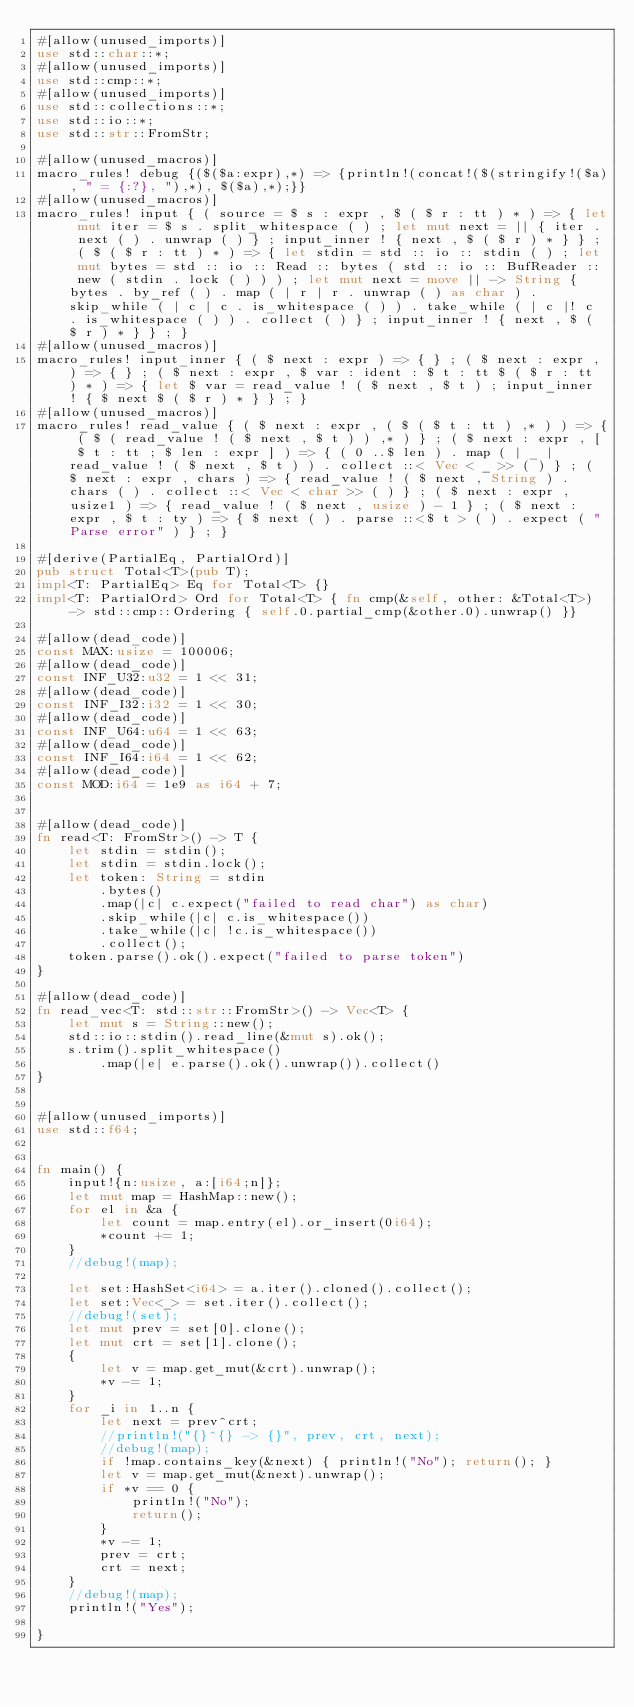<code> <loc_0><loc_0><loc_500><loc_500><_Rust_>#[allow(unused_imports)]
use std::char::*;
#[allow(unused_imports)]
use std::cmp::*;
#[allow(unused_imports)]
use std::collections::*;
use std::io::*;
use std::str::FromStr;

#[allow(unused_macros)]
macro_rules! debug {($($a:expr),*) => {println!(concat!($(stringify!($a), " = {:?}, "),*), $($a),*);}}
#[allow(unused_macros)]
macro_rules! input { ( source = $ s : expr , $ ( $ r : tt ) * ) => { let mut iter = $ s . split_whitespace ( ) ; let mut next = || { iter . next ( ) . unwrap ( ) } ; input_inner ! { next , $ ( $ r ) * } } ; ( $ ( $ r : tt ) * ) => { let stdin = std :: io :: stdin ( ) ; let mut bytes = std :: io :: Read :: bytes ( std :: io :: BufReader :: new ( stdin . lock ( ) ) ) ; let mut next = move || -> String { bytes . by_ref ( ) . map ( | r | r . unwrap ( ) as char ) . skip_while ( | c | c . is_whitespace ( ) ) . take_while ( | c |! c . is_whitespace ( ) ) . collect ( ) } ; input_inner ! { next , $ ( $ r ) * } } ; }
#[allow(unused_macros)]
macro_rules! input_inner { ( $ next : expr ) => { } ; ( $ next : expr , ) => { } ; ( $ next : expr , $ var : ident : $ t : tt $ ( $ r : tt ) * ) => { let $ var = read_value ! ( $ next , $ t ) ; input_inner ! { $ next $ ( $ r ) * } } ; }
#[allow(unused_macros)]
macro_rules! read_value { ( $ next : expr , ( $ ( $ t : tt ) ,* ) ) => { ( $ ( read_value ! ( $ next , $ t ) ) ,* ) } ; ( $ next : expr , [ $ t : tt ; $ len : expr ] ) => { ( 0 ..$ len ) . map ( | _ | read_value ! ( $ next , $ t ) ) . collect ::< Vec < _ >> ( ) } ; ( $ next : expr , chars ) => { read_value ! ( $ next , String ) . chars ( ) . collect ::< Vec < char >> ( ) } ; ( $ next : expr , usize1 ) => { read_value ! ( $ next , usize ) - 1 } ; ( $ next : expr , $ t : ty ) => { $ next ( ) . parse ::<$ t > ( ) . expect ( "Parse error" ) } ; }

#[derive(PartialEq, PartialOrd)]
pub struct Total<T>(pub T);
impl<T: PartialEq> Eq for Total<T> {}
impl<T: PartialOrd> Ord for Total<T> { fn cmp(&self, other: &Total<T>) -> std::cmp::Ordering { self.0.partial_cmp(&other.0).unwrap() }}

#[allow(dead_code)]
const MAX:usize = 100006;
#[allow(dead_code)]
const INF_U32:u32 = 1 << 31;
#[allow(dead_code)]
const INF_I32:i32 = 1 << 30;
#[allow(dead_code)]
const INF_U64:u64 = 1 << 63;
#[allow(dead_code)]
const INF_I64:i64 = 1 << 62;
#[allow(dead_code)]
const MOD:i64 = 1e9 as i64 + 7;


#[allow(dead_code)]
fn read<T: FromStr>() -> T {
    let stdin = stdin();
    let stdin = stdin.lock();
    let token: String = stdin
        .bytes()
        .map(|c| c.expect("failed to read char") as char)
        .skip_while(|c| c.is_whitespace())
        .take_while(|c| !c.is_whitespace())
        .collect();
    token.parse().ok().expect("failed to parse token")
}

#[allow(dead_code)]
fn read_vec<T: std::str::FromStr>() -> Vec<T> {
    let mut s = String::new();
    std::io::stdin().read_line(&mut s).ok();
    s.trim().split_whitespace()
        .map(|e| e.parse().ok().unwrap()).collect()
}


#[allow(unused_imports)]
use std::f64;


fn main() {
    input!{n:usize, a:[i64;n]};
    let mut map = HashMap::new();
    for el in &a {
        let count = map.entry(el).or_insert(0i64);
        *count += 1;
    }
    //debug!(map);

    let set:HashSet<i64> = a.iter().cloned().collect();
    let set:Vec<_> = set.iter().collect();
    //debug!(set);
    let mut prev = set[0].clone();
    let mut crt = set[1].clone();
    {
        let v = map.get_mut(&crt).unwrap();
        *v -= 1;
    }
    for _i in 1..n {
        let next = prev^crt;
        //println!("{}^{} -> {}", prev, crt, next);
        //debug!(map);
        if !map.contains_key(&next) { println!("No"); return(); }
        let v = map.get_mut(&next).unwrap();
        if *v == 0 {
            println!("No");
            return();
        }
        *v -= 1;
        prev = crt;
        crt = next;
    }
    //debug!(map);
    println!("Yes");

}</code> 